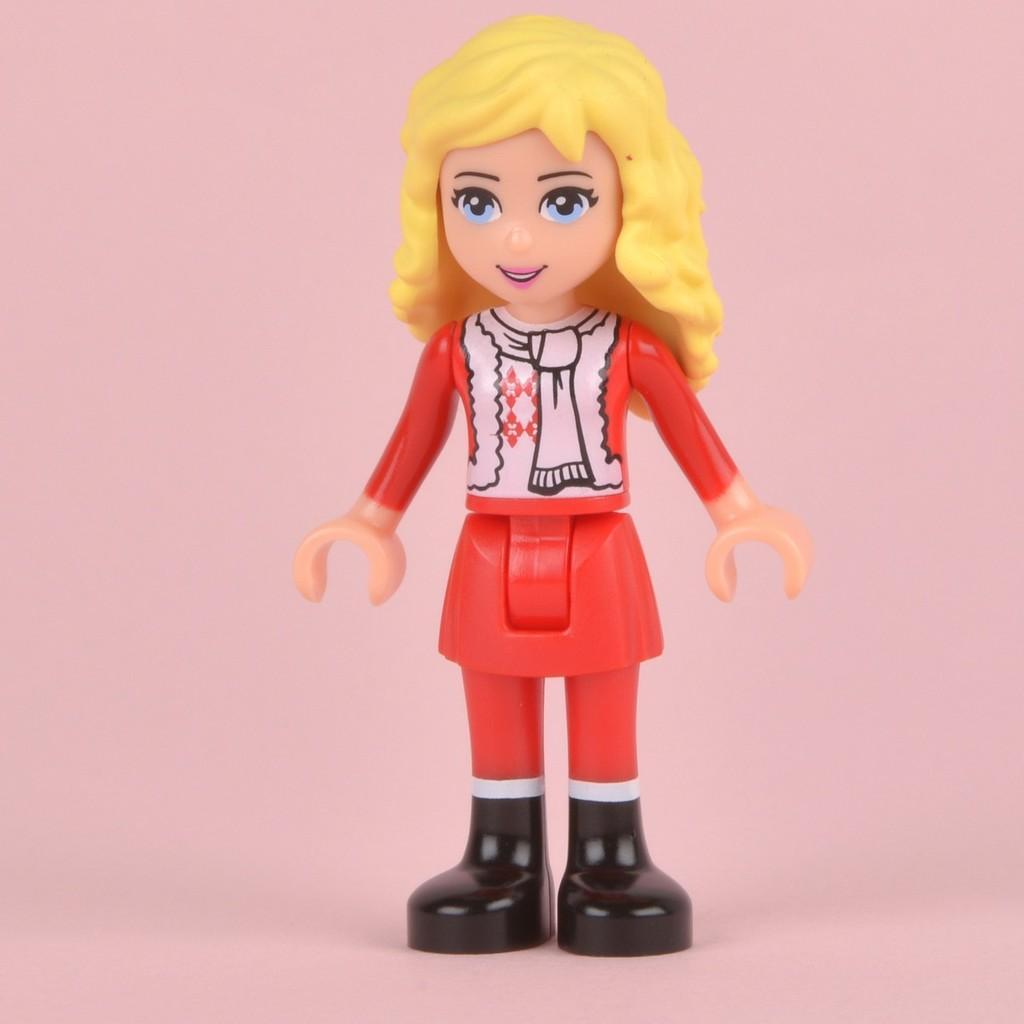Please provide a concise description of this image. In this image I can see a girl doll in the front. I can see the color of the doll is red, white, yellow and black. I can also see pink colour in the background. 